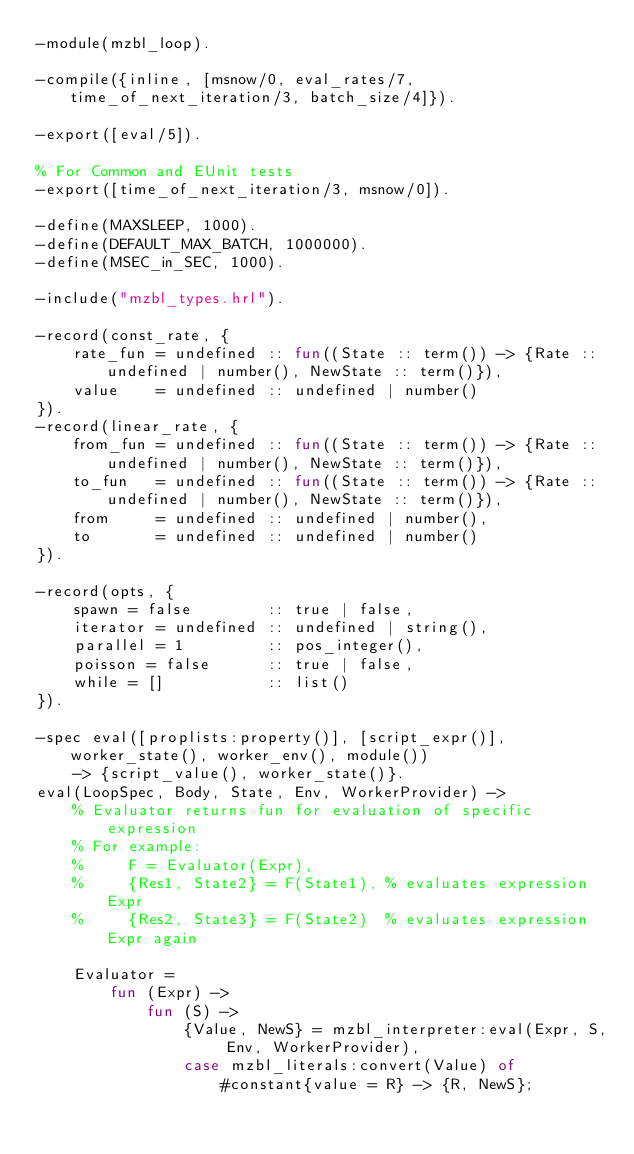Convert code to text. <code><loc_0><loc_0><loc_500><loc_500><_Erlang_>-module(mzbl_loop).

-compile({inline, [msnow/0, eval_rates/7, time_of_next_iteration/3, batch_size/4]}).

-export([eval/5]).

% For Common and EUnit tests
-export([time_of_next_iteration/3, msnow/0]).

-define(MAXSLEEP, 1000).
-define(DEFAULT_MAX_BATCH, 1000000).
-define(MSEC_in_SEC, 1000).

-include("mzbl_types.hrl").

-record(const_rate, {
    rate_fun = undefined :: fun((State :: term()) -> {Rate :: undefined | number(), NewState :: term()}),
    value    = undefined :: undefined | number()
}).
-record(linear_rate, {
    from_fun = undefined :: fun((State :: term()) -> {Rate :: undefined | number(), NewState :: term()}),
    to_fun   = undefined :: fun((State :: term()) -> {Rate :: undefined | number(), NewState :: term()}),
    from     = undefined :: undefined | number(),
    to       = undefined :: undefined | number()
}).

-record(opts, {
    spawn = false        :: true | false,
    iterator = undefined :: undefined | string(),
    parallel = 1         :: pos_integer(),
    poisson = false      :: true | false,
    while = []           :: list()
}).

-spec eval([proplists:property()], [script_expr()], worker_state(), worker_env(), module())
    -> {script_value(), worker_state()}.
eval(LoopSpec, Body, State, Env, WorkerProvider) ->
    % Evaluator returns fun for evaluation of specific expression
    % For example:
    %     F = Evaluator(Expr),
    %     {Res1, State2} = F(State1), % evaluates expression Expr
    %     {Res2, State3} = F(State2)  % evaluates expression Expr again

    Evaluator =
        fun (Expr) ->
            fun (S) ->
                {Value, NewS} = mzbl_interpreter:eval(Expr, S, Env, WorkerProvider),
                case mzbl_literals:convert(Value) of
                    #constant{value = R} -> {R, NewS};</code> 